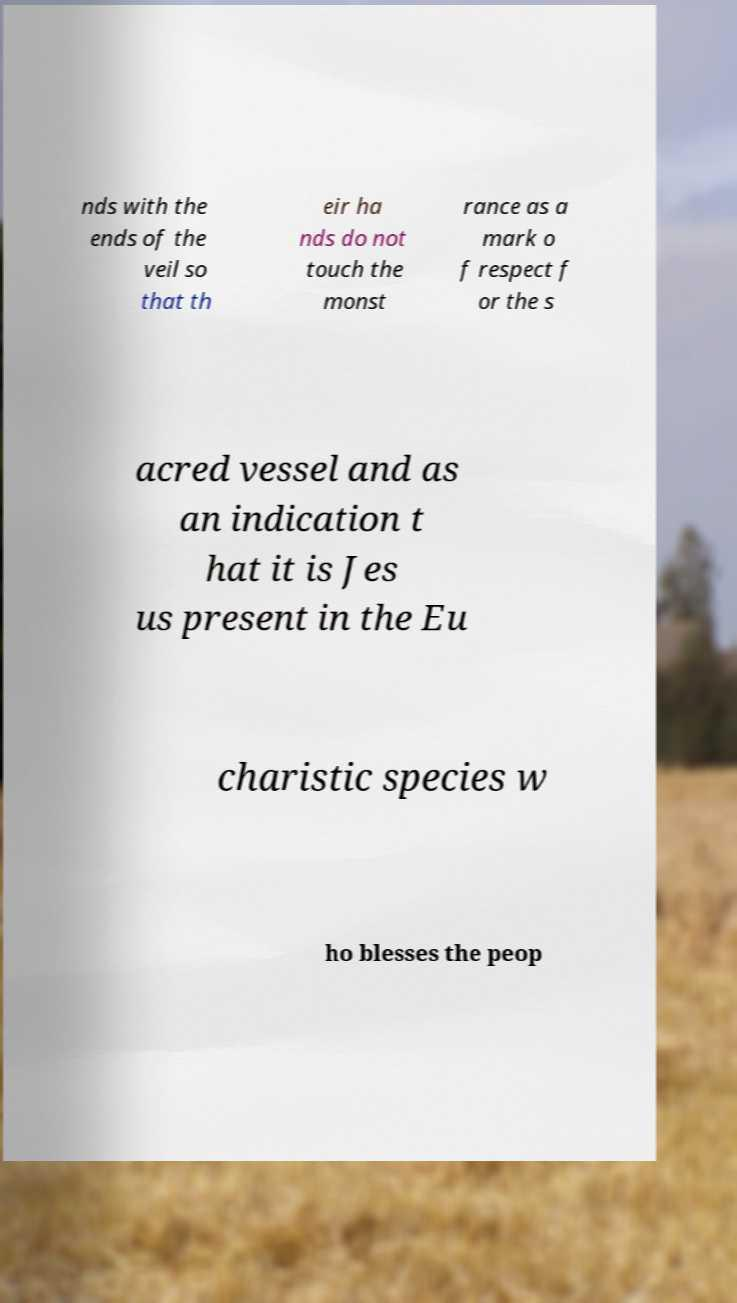Please read and relay the text visible in this image. What does it say? nds with the ends of the veil so that th eir ha nds do not touch the monst rance as a mark o f respect f or the s acred vessel and as an indication t hat it is Jes us present in the Eu charistic species w ho blesses the peop 